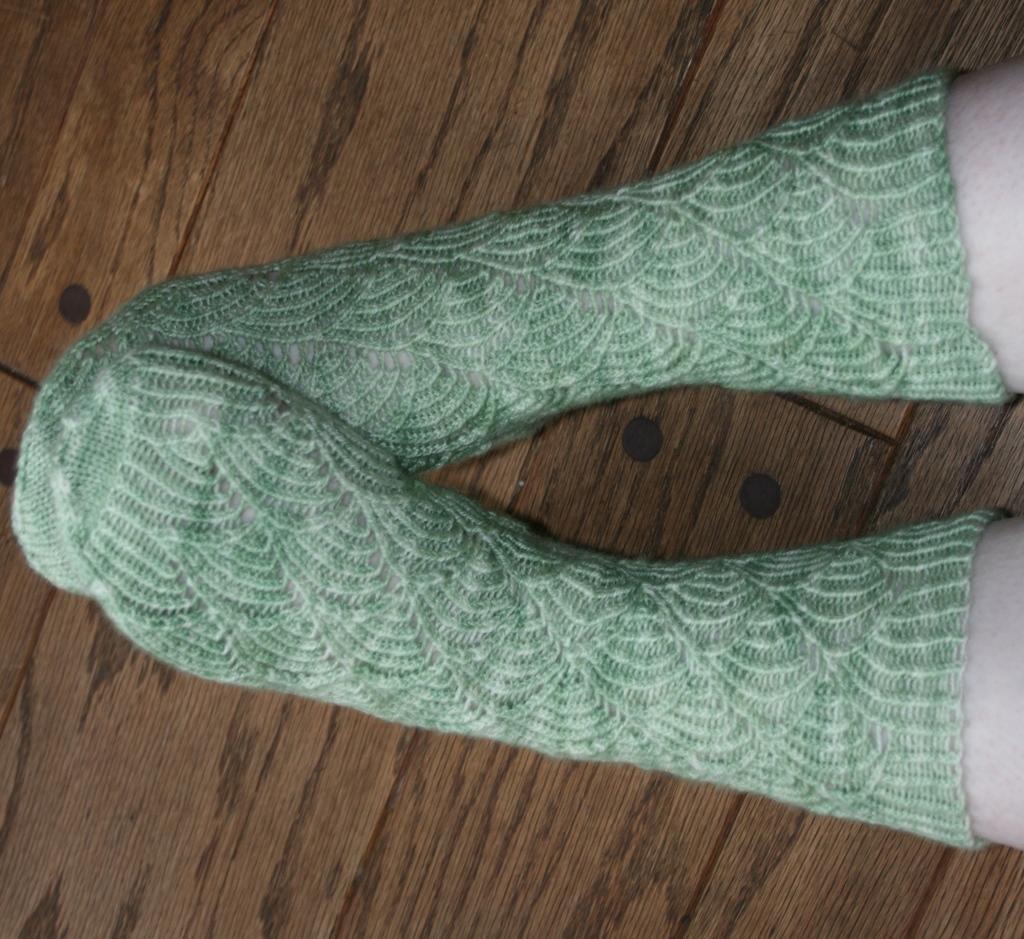Please provide a concise description of this image. In this image there are legs of the person which are visible and on the legs there are socks which are green in colour. 